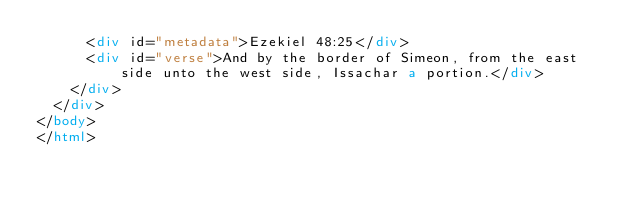<code> <loc_0><loc_0><loc_500><loc_500><_HTML_>      <div id="metadata">Ezekiel 48:25</div>
      <div id="verse">And by the border of Simeon, from the east side unto the west side, Issachar a portion.</div>
    </div>
  </div>
</body>
</html></code> 